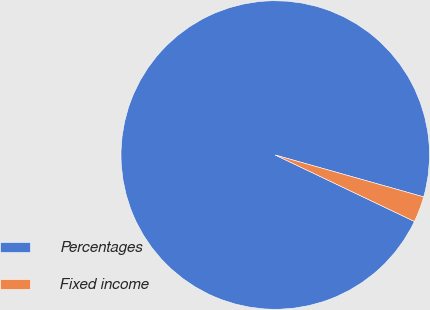<chart> <loc_0><loc_0><loc_500><loc_500><pie_chart><fcel>Percentages<fcel>Fixed income<nl><fcel>97.29%<fcel>2.71%<nl></chart> 